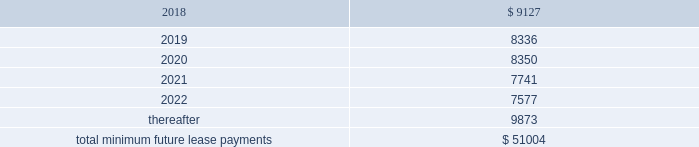As of december 31 , 2017 , the aggregate future minimum payments under non-cancelable operating leases consist of the following ( in thousands ) : years ending december 31 .
Rent expense for all operating leases amounted to $ 9.4 million , $ 8.1 million and $ 5.4 million for the years ended december 31 , 2017 , 2016 and 2015 , respectively .
Financing obligation 2014build-to-suit lease in august 2012 , we executed a lease for a building then under construction in santa clara , california to serve as our headquarters .
The lease term is 120 months and commenced in august 2013 .
Based on the terms of the lease agreement and due to our involvement in certain aspects of the construction , we were deemed the owner of the building ( for accounting purposes only ) during the construction period .
Upon completion of construction in 2013 , we concluded that we had forms of continued economic involvement in the facility , and therefore did not meet with the provisions for sale-leaseback accounting .
We continue to maintain involvement in the property post construction and lack transferability of the risks and rewards of ownership , due to our required maintenance of a $ 4.0 million letter of credit , in addition to our ability and option to sublease our portion of the leased building for fees substantially higher than our base rate .
Therefore , the lease is accounted for as a financing obligation and lease payments will be attributed to ( 1 ) a reduction of the principal financing obligation ; ( 2 ) imputed interest expense ; and ( 3 ) land lease expense , representing an imputed cost to lease the underlying land of the building .
At the conclusion of the initial lease term , we will de-recognize both the net book values of the asset and the remaining financing obligation .
As of december 31 , 2017 and 2016 , we have recorded assets of $ 53.4 million , representing the total costs of the building and improvements incurred , including the costs paid by the lessor ( the legal owner of the building ) and additional improvement costs paid by us , and a corresponding financing obligation of $ 39.6 million and $ 41.2 million , respectively .
As of december 31 , 2017 , $ 1.9 million and $ 37.7 million were recorded as short-term and long-term financing obligations , respectively .
Land lease expense under our lease financing obligation amounted to $ 1.3 million for each of the years ended december 31 , 2017 , 2016 and 2015 respectively. .
What portion of the future future minimum payments under non-cancelable operating leases is due in the next 12 months? 
Computations: (9127 / 51004)
Answer: 0.17895. 